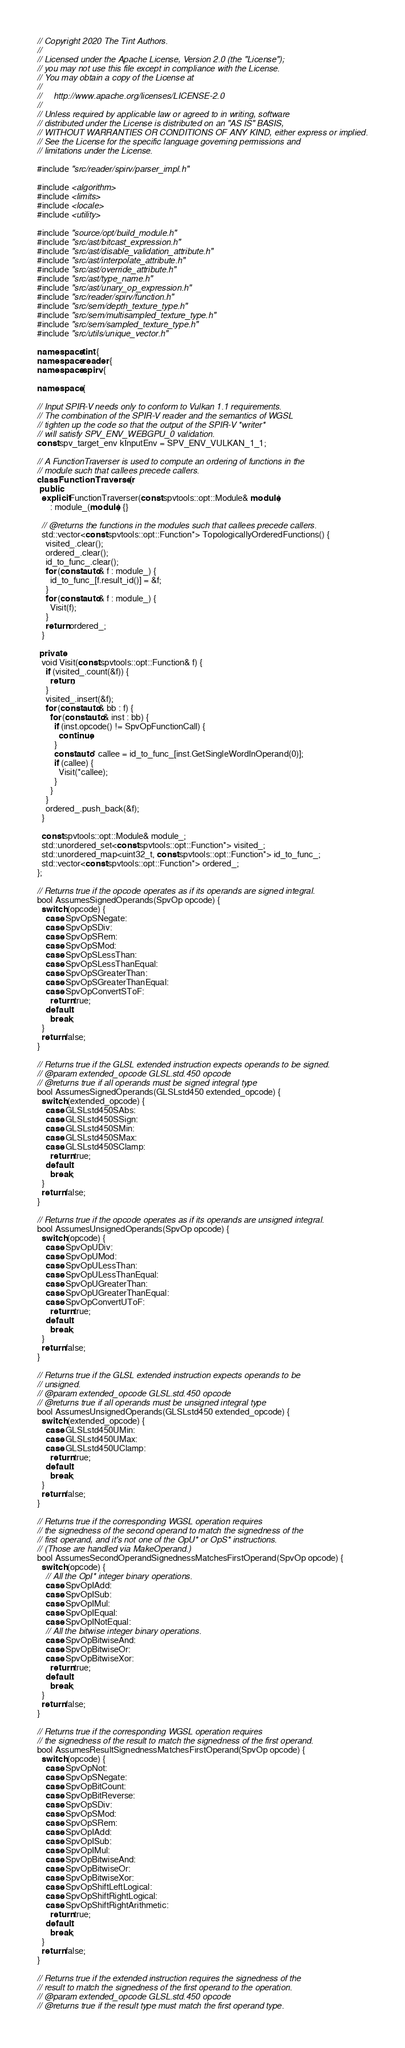Convert code to text. <code><loc_0><loc_0><loc_500><loc_500><_C++_>// Copyright 2020 The Tint Authors.
//
// Licensed under the Apache License, Version 2.0 (the "License");
// you may not use this file except in compliance with the License.
// You may obtain a copy of the License at
//
//     http://www.apache.org/licenses/LICENSE-2.0
//
// Unless required by applicable law or agreed to in writing, software
// distributed under the License is distributed on an "AS IS" BASIS,
// WITHOUT WARRANTIES OR CONDITIONS OF ANY KIND, either express or implied.
// See the License for the specific language governing permissions and
// limitations under the License.

#include "src/reader/spirv/parser_impl.h"

#include <algorithm>
#include <limits>
#include <locale>
#include <utility>

#include "source/opt/build_module.h"
#include "src/ast/bitcast_expression.h"
#include "src/ast/disable_validation_attribute.h"
#include "src/ast/interpolate_attribute.h"
#include "src/ast/override_attribute.h"
#include "src/ast/type_name.h"
#include "src/ast/unary_op_expression.h"
#include "src/reader/spirv/function.h"
#include "src/sem/depth_texture_type.h"
#include "src/sem/multisampled_texture_type.h"
#include "src/sem/sampled_texture_type.h"
#include "src/utils/unique_vector.h"

namespace tint {
namespace reader {
namespace spirv {

namespace {

// Input SPIR-V needs only to conform to Vulkan 1.1 requirements.
// The combination of the SPIR-V reader and the semantics of WGSL
// tighten up the code so that the output of the SPIR-V *writer*
// will satisfy SPV_ENV_WEBGPU_0 validation.
const spv_target_env kInputEnv = SPV_ENV_VULKAN_1_1;

// A FunctionTraverser is used to compute an ordering of functions in the
// module such that callees precede callers.
class FunctionTraverser {
 public:
  explicit FunctionTraverser(const spvtools::opt::Module& module)
      : module_(module) {}

  // @returns the functions in the modules such that callees precede callers.
  std::vector<const spvtools::opt::Function*> TopologicallyOrderedFunctions() {
    visited_.clear();
    ordered_.clear();
    id_to_func_.clear();
    for (const auto& f : module_) {
      id_to_func_[f.result_id()] = &f;
    }
    for (const auto& f : module_) {
      Visit(f);
    }
    return ordered_;
  }

 private:
  void Visit(const spvtools::opt::Function& f) {
    if (visited_.count(&f)) {
      return;
    }
    visited_.insert(&f);
    for (const auto& bb : f) {
      for (const auto& inst : bb) {
        if (inst.opcode() != SpvOpFunctionCall) {
          continue;
        }
        const auto* callee = id_to_func_[inst.GetSingleWordInOperand(0)];
        if (callee) {
          Visit(*callee);
        }
      }
    }
    ordered_.push_back(&f);
  }

  const spvtools::opt::Module& module_;
  std::unordered_set<const spvtools::opt::Function*> visited_;
  std::unordered_map<uint32_t, const spvtools::opt::Function*> id_to_func_;
  std::vector<const spvtools::opt::Function*> ordered_;
};

// Returns true if the opcode operates as if its operands are signed integral.
bool AssumesSignedOperands(SpvOp opcode) {
  switch (opcode) {
    case SpvOpSNegate:
    case SpvOpSDiv:
    case SpvOpSRem:
    case SpvOpSMod:
    case SpvOpSLessThan:
    case SpvOpSLessThanEqual:
    case SpvOpSGreaterThan:
    case SpvOpSGreaterThanEqual:
    case SpvOpConvertSToF:
      return true;
    default:
      break;
  }
  return false;
}

// Returns true if the GLSL extended instruction expects operands to be signed.
// @param extended_opcode GLSL.std.450 opcode
// @returns true if all operands must be signed integral type
bool AssumesSignedOperands(GLSLstd450 extended_opcode) {
  switch (extended_opcode) {
    case GLSLstd450SAbs:
    case GLSLstd450SSign:
    case GLSLstd450SMin:
    case GLSLstd450SMax:
    case GLSLstd450SClamp:
      return true;
    default:
      break;
  }
  return false;
}

// Returns true if the opcode operates as if its operands are unsigned integral.
bool AssumesUnsignedOperands(SpvOp opcode) {
  switch (opcode) {
    case SpvOpUDiv:
    case SpvOpUMod:
    case SpvOpULessThan:
    case SpvOpULessThanEqual:
    case SpvOpUGreaterThan:
    case SpvOpUGreaterThanEqual:
    case SpvOpConvertUToF:
      return true;
    default:
      break;
  }
  return false;
}

// Returns true if the GLSL extended instruction expects operands to be
// unsigned.
// @param extended_opcode GLSL.std.450 opcode
// @returns true if all operands must be unsigned integral type
bool AssumesUnsignedOperands(GLSLstd450 extended_opcode) {
  switch (extended_opcode) {
    case GLSLstd450UMin:
    case GLSLstd450UMax:
    case GLSLstd450UClamp:
      return true;
    default:
      break;
  }
  return false;
}

// Returns true if the corresponding WGSL operation requires
// the signedness of the second operand to match the signedness of the
// first operand, and it's not one of the OpU* or OpS* instructions.
// (Those are handled via MakeOperand.)
bool AssumesSecondOperandSignednessMatchesFirstOperand(SpvOp opcode) {
  switch (opcode) {
    // All the OpI* integer binary operations.
    case SpvOpIAdd:
    case SpvOpISub:
    case SpvOpIMul:
    case SpvOpIEqual:
    case SpvOpINotEqual:
    // All the bitwise integer binary operations.
    case SpvOpBitwiseAnd:
    case SpvOpBitwiseOr:
    case SpvOpBitwiseXor:
      return true;
    default:
      break;
  }
  return false;
}

// Returns true if the corresponding WGSL operation requires
// the signedness of the result to match the signedness of the first operand.
bool AssumesResultSignednessMatchesFirstOperand(SpvOp opcode) {
  switch (opcode) {
    case SpvOpNot:
    case SpvOpSNegate:
    case SpvOpBitCount:
    case SpvOpBitReverse:
    case SpvOpSDiv:
    case SpvOpSMod:
    case SpvOpSRem:
    case SpvOpIAdd:
    case SpvOpISub:
    case SpvOpIMul:
    case SpvOpBitwiseAnd:
    case SpvOpBitwiseOr:
    case SpvOpBitwiseXor:
    case SpvOpShiftLeftLogical:
    case SpvOpShiftRightLogical:
    case SpvOpShiftRightArithmetic:
      return true;
    default:
      break;
  }
  return false;
}

// Returns true if the extended instruction requires the signedness of the
// result to match the signedness of the first operand to the operation.
// @param extended_opcode GLSL.std.450 opcode
// @returns true if the result type must match the first operand type.</code> 